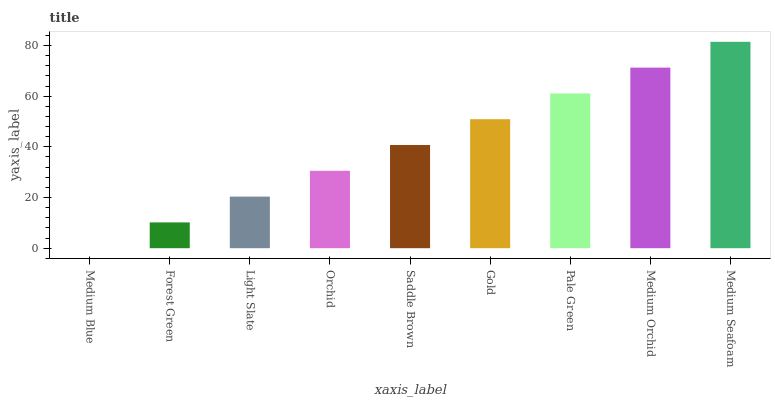Is Medium Blue the minimum?
Answer yes or no. Yes. Is Medium Seafoam the maximum?
Answer yes or no. Yes. Is Forest Green the minimum?
Answer yes or no. No. Is Forest Green the maximum?
Answer yes or no. No. Is Forest Green greater than Medium Blue?
Answer yes or no. Yes. Is Medium Blue less than Forest Green?
Answer yes or no. Yes. Is Medium Blue greater than Forest Green?
Answer yes or no. No. Is Forest Green less than Medium Blue?
Answer yes or no. No. Is Saddle Brown the high median?
Answer yes or no. Yes. Is Saddle Brown the low median?
Answer yes or no. Yes. Is Medium Orchid the high median?
Answer yes or no. No. Is Forest Green the low median?
Answer yes or no. No. 